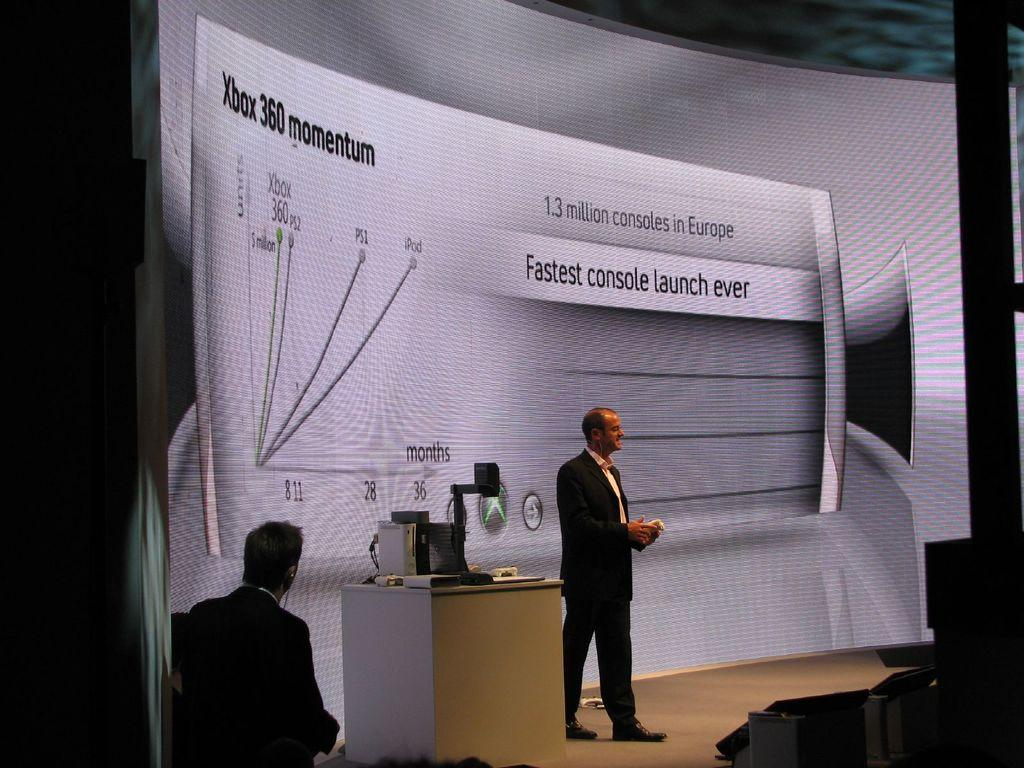How many people are in the image? There are two persons in the image. What is located in the middle of the image? There is a screen in the image. Where is the table positioned in the image? The table is at the bottom of the image. What device is on the table? There is a laptop on the table. What type of doctor is present in the image? There is no doctor present in the image. How are the two persons in the image dividing their tasks? The provided facts do not give information about the tasks or roles of the two persons in the image, so we cannot determine how they are dividing their tasks. 